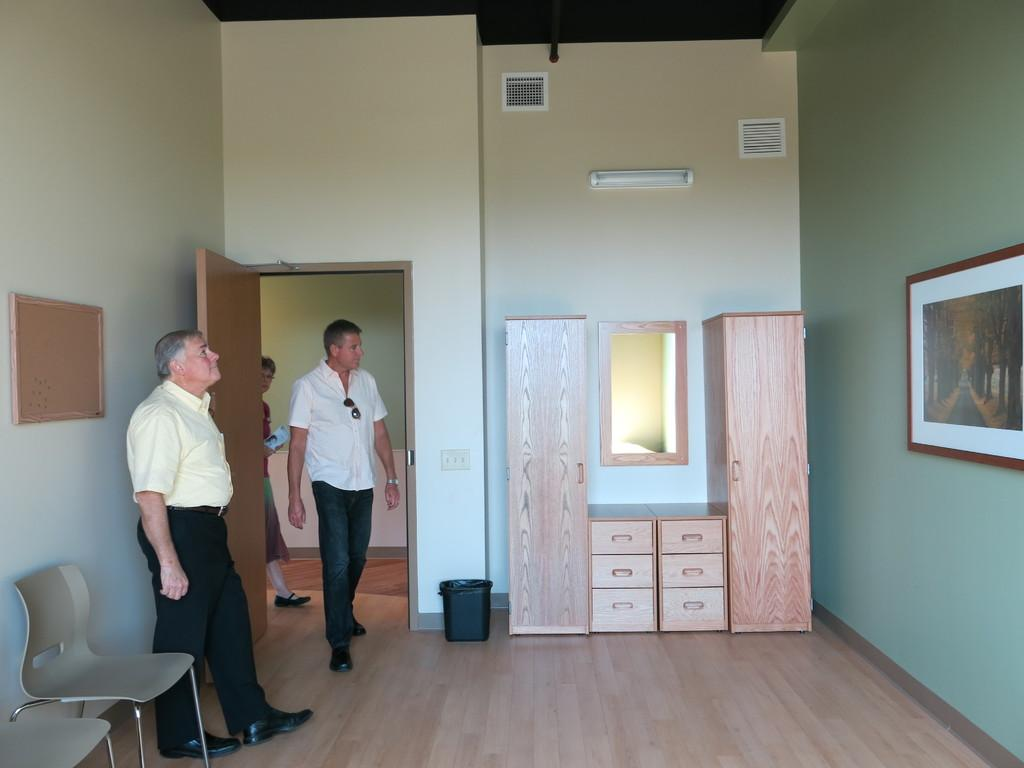How many people are in the image? There are three people in the image: two men and one woman. What type of furniture is present in the image? There are chairs in the image. What is the purpose of the dustbin in the room? The dustbin is used for disposing of waste in the room. What type of storage unit is present in the room? There is a cupboard in the room for storage. What color is the balloon held by the woman in the image? There is no balloon present in the image. How is the uncle related to the people in the image? There is no uncle mentioned or depicted in the image. 